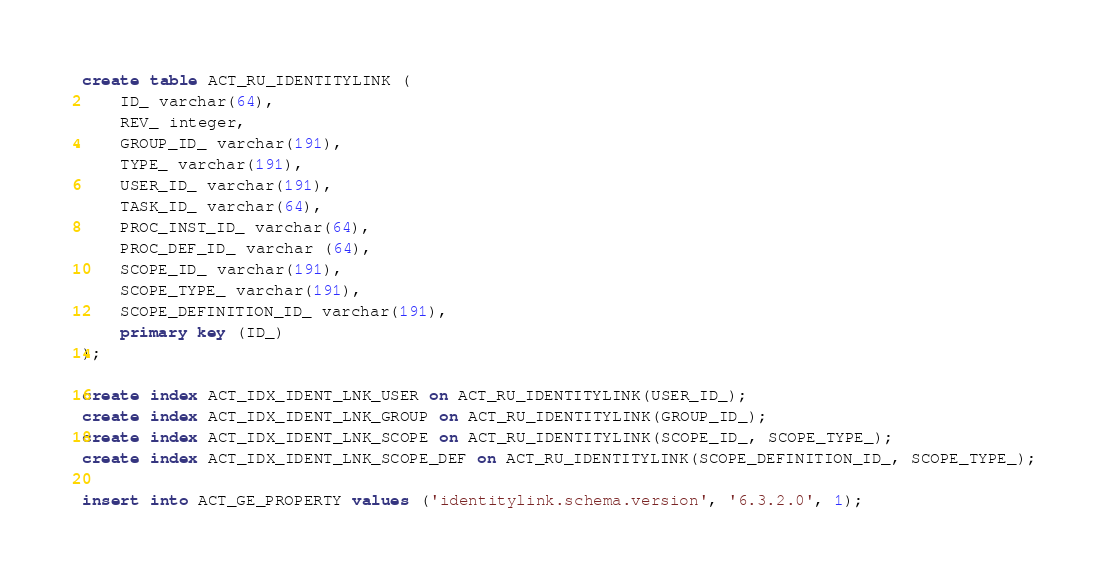<code> <loc_0><loc_0><loc_500><loc_500><_SQL_>create table ACT_RU_IDENTITYLINK (
    ID_ varchar(64),
    REV_ integer,
    GROUP_ID_ varchar(191),
    TYPE_ varchar(191),
    USER_ID_ varchar(191),
    TASK_ID_ varchar(64),
    PROC_INST_ID_ varchar(64),
    PROC_DEF_ID_ varchar (64),
    SCOPE_ID_ varchar(191),
    SCOPE_TYPE_ varchar(191),
    SCOPE_DEFINITION_ID_ varchar(191),
    primary key (ID_)
);

create index ACT_IDX_IDENT_LNK_USER on ACT_RU_IDENTITYLINK(USER_ID_);
create index ACT_IDX_IDENT_LNK_GROUP on ACT_RU_IDENTITYLINK(GROUP_ID_);
create index ACT_IDX_IDENT_LNK_SCOPE on ACT_RU_IDENTITYLINK(SCOPE_ID_, SCOPE_TYPE_);
create index ACT_IDX_IDENT_LNK_SCOPE_DEF on ACT_RU_IDENTITYLINK(SCOPE_DEFINITION_ID_, SCOPE_TYPE_);

insert into ACT_GE_PROPERTY values ('identitylink.schema.version', '6.3.2.0', 1);</code> 